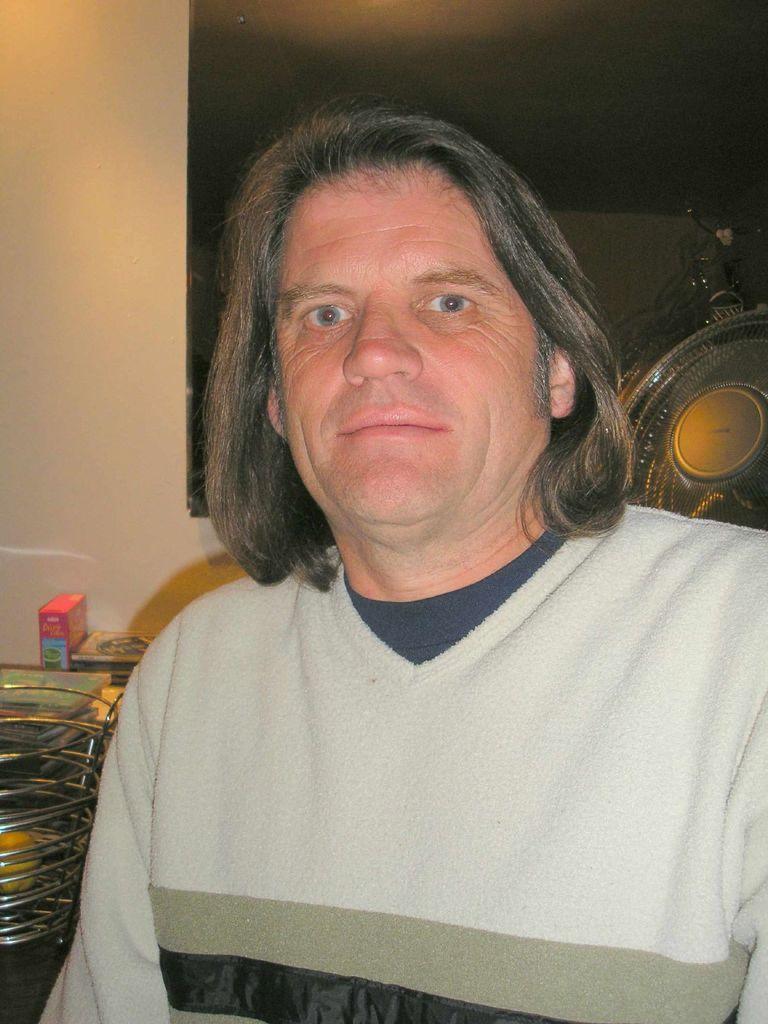Describe this image in one or two sentences. In this image I see a man who is wearing t-shirt which is of white, grey and black in color and I see the wall which is of cream in color and I see few things over here and it is a bit dark over here and I see a thing over here. 